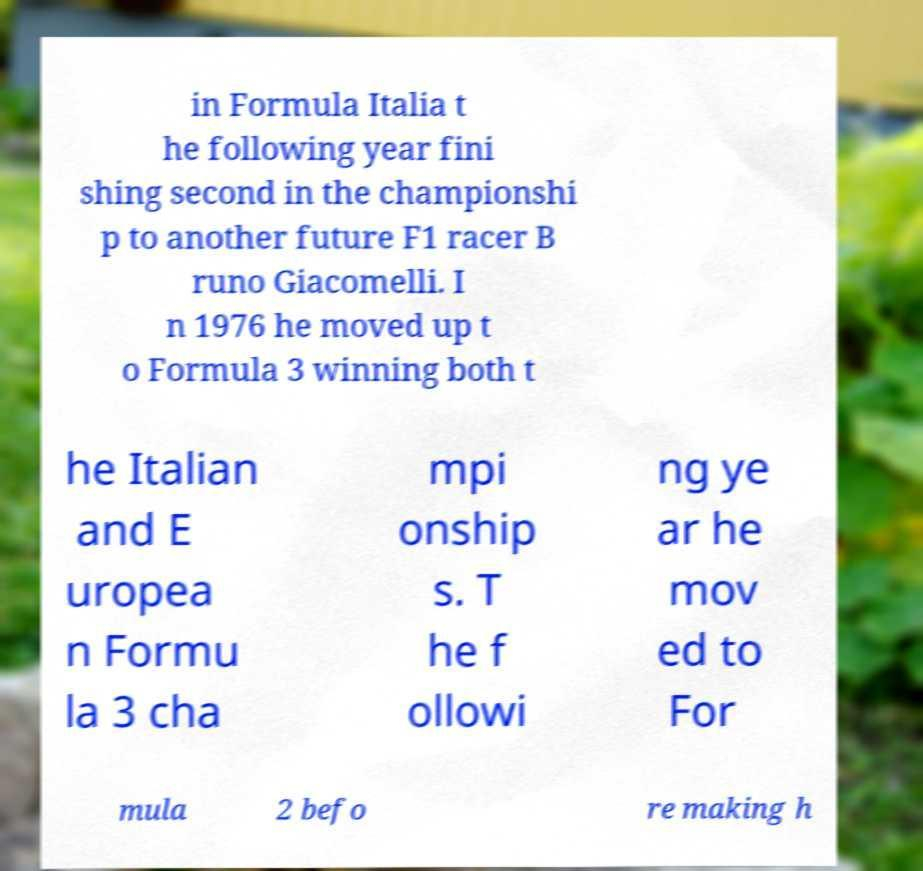Can you accurately transcribe the text from the provided image for me? in Formula Italia t he following year fini shing second in the championshi p to another future F1 racer B runo Giacomelli. I n 1976 he moved up t o Formula 3 winning both t he Italian and E uropea n Formu la 3 cha mpi onship s. T he f ollowi ng ye ar he mov ed to For mula 2 befo re making h 